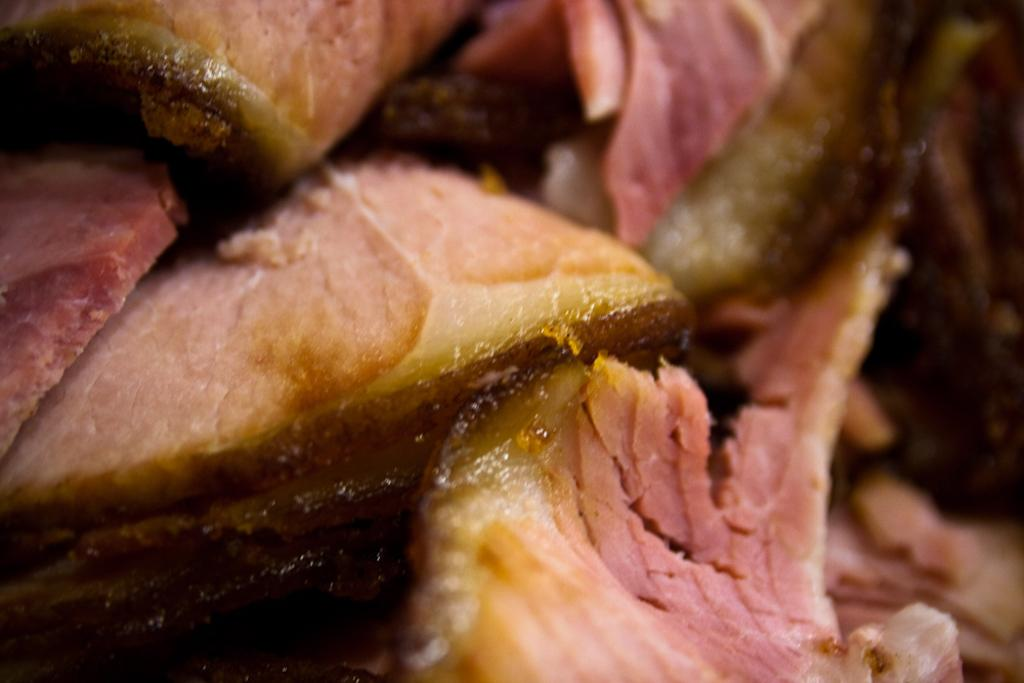What is the focus of the image? The image is a zoomed in picture of meat. Can you describe the subject of the image in more detail? The subject of the image is meat, which is the main focus of the picture. How many bats are flying around the meat in the image? There are no bats present in the image; it only features a close-up of meat. 